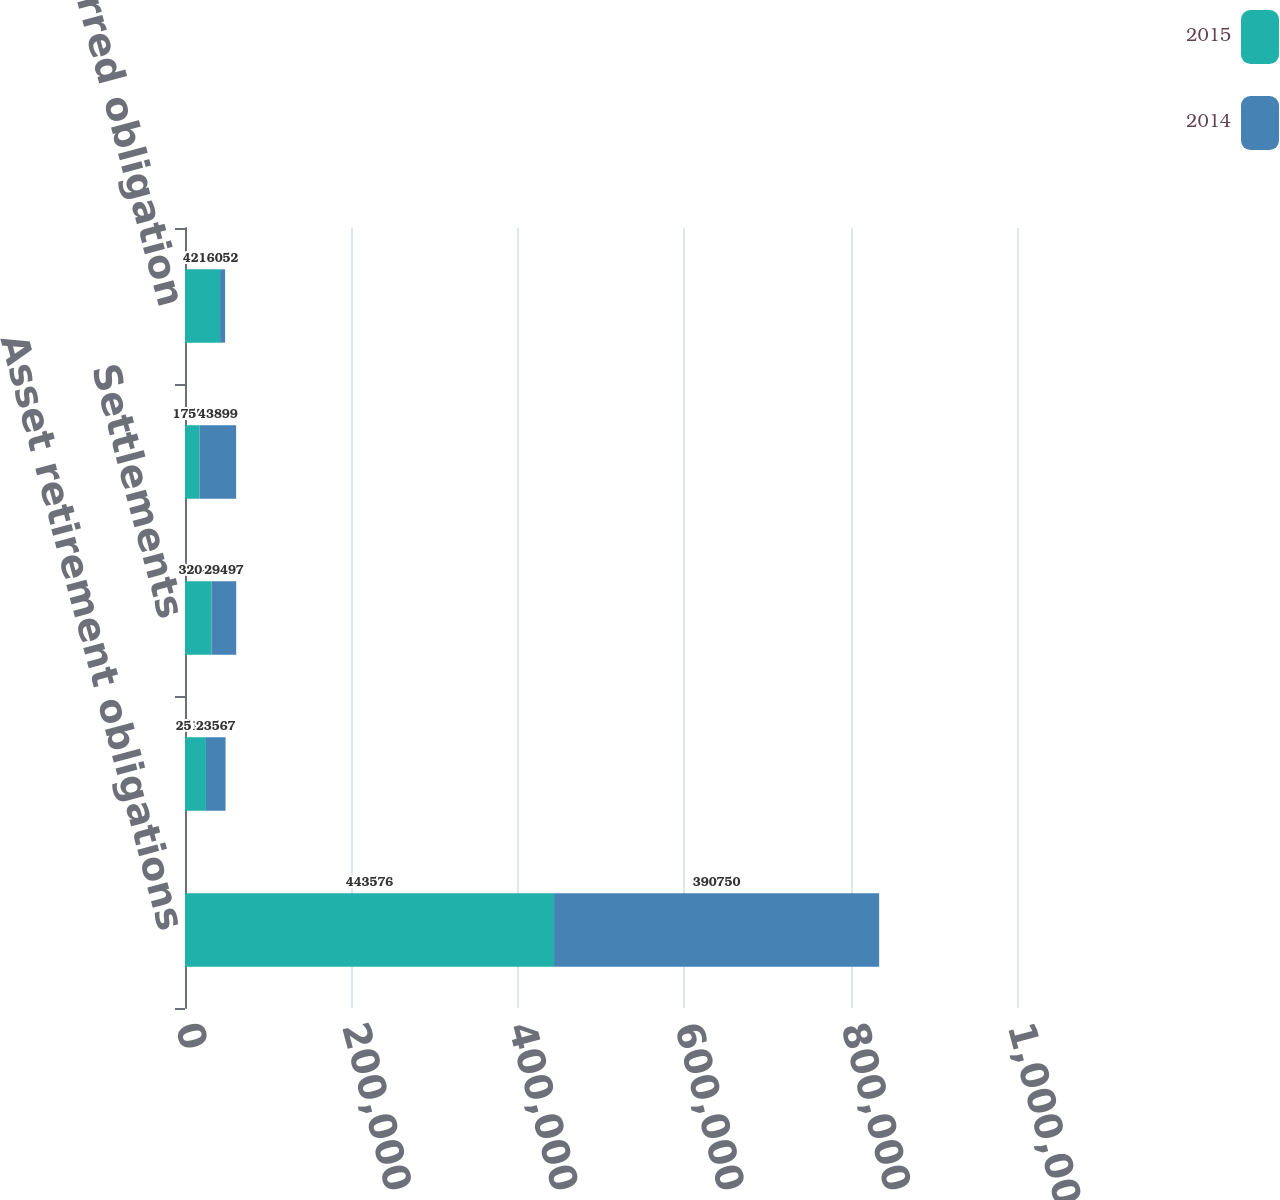Convert chart. <chart><loc_0><loc_0><loc_500><loc_500><stacked_bar_chart><ecel><fcel>Asset retirement obligations<fcel>Accretion expense<fcel>Settlements<fcel>Estimated cash flow revisions<fcel>Newly incurred obligation<nl><fcel>2015<fcel>443576<fcel>25163<fcel>32048<fcel>17556<fcel>42155<nl><fcel>2014<fcel>390750<fcel>23567<fcel>29497<fcel>43899<fcel>6052<nl></chart> 